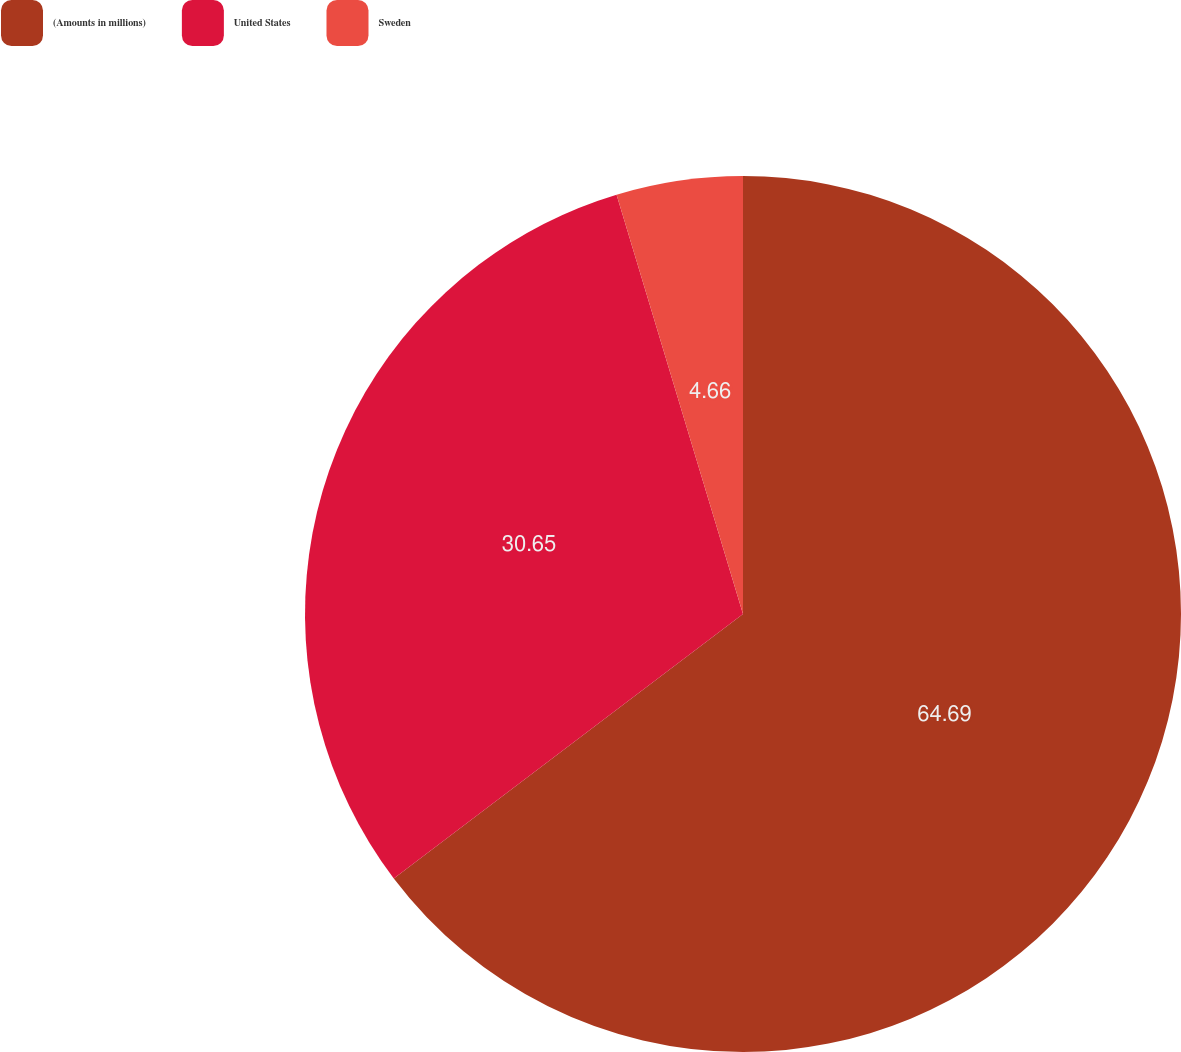Convert chart. <chart><loc_0><loc_0><loc_500><loc_500><pie_chart><fcel>(Amounts in millions)<fcel>United States<fcel>Sweden<nl><fcel>64.68%<fcel>30.65%<fcel>4.66%<nl></chart> 